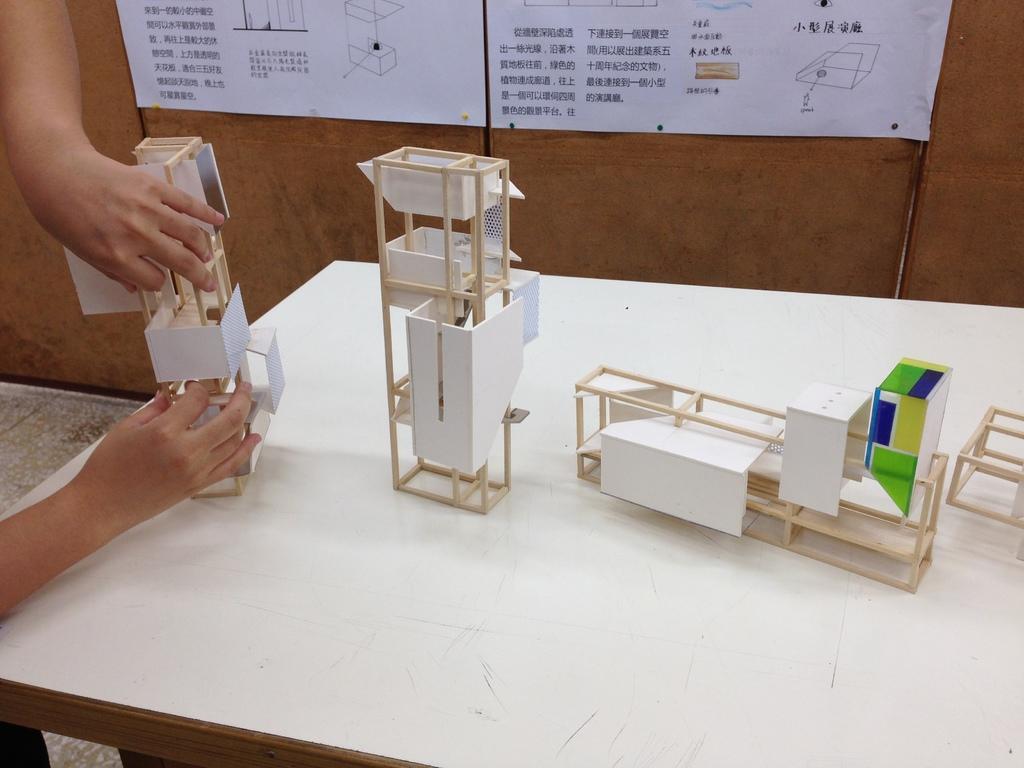Describe this image in one or two sentences. In this picture, we see an architecture models are placed on the white table. On the left side, we see the hands of the person holding this model. In the background, we see a wooden wall on which white charts are placed. We see some text written on the charts. 